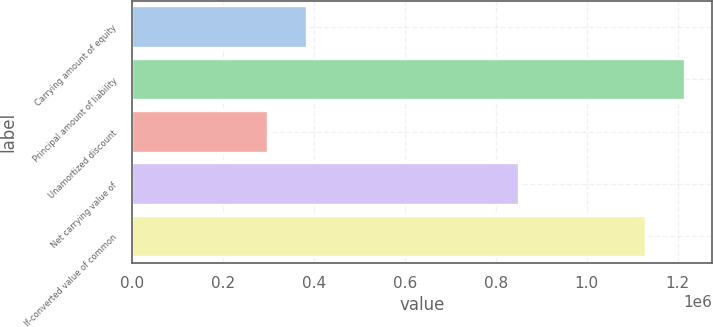Convert chart. <chart><loc_0><loc_0><loc_500><loc_500><bar_chart><fcel>Carrying amount of equity<fcel>Principal amount of liability<fcel>Unamortized discount<fcel>Net carrying value of<fcel>If-converted value of common<nl><fcel>384166<fcel>1.21594e+06<fcel>299073<fcel>850927<fcel>1.13085e+06<nl></chart> 